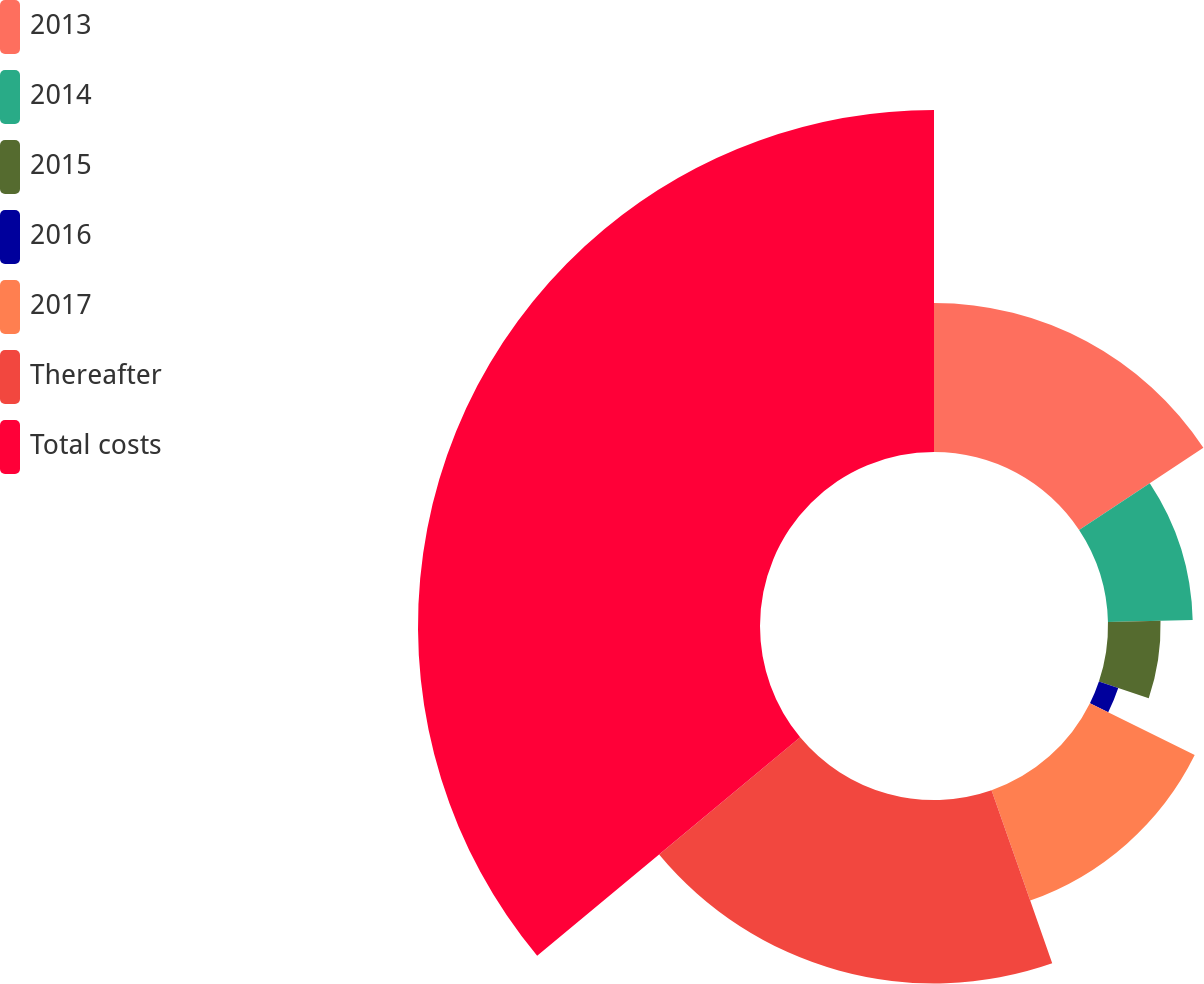Convert chart to OTSL. <chart><loc_0><loc_0><loc_500><loc_500><pie_chart><fcel>2013<fcel>2014<fcel>2015<fcel>2016<fcel>2017<fcel>Thereafter<fcel>Total costs<nl><fcel>15.7%<fcel>8.93%<fcel>5.54%<fcel>2.15%<fcel>12.32%<fcel>19.33%<fcel>36.04%<nl></chart> 